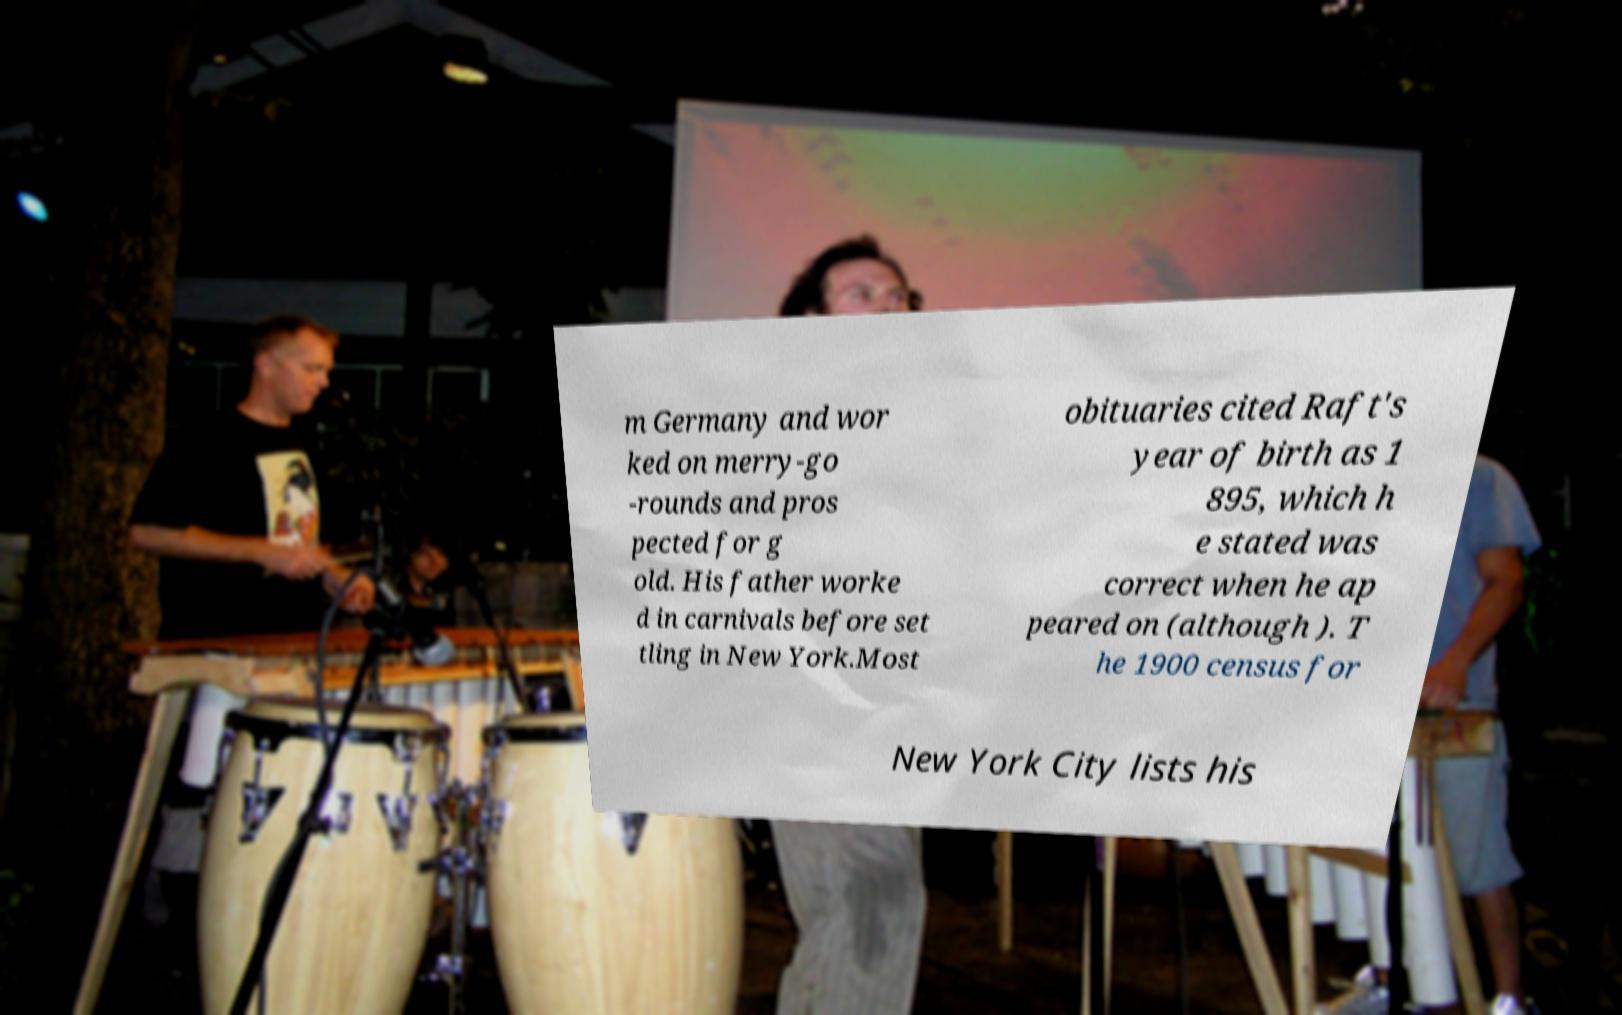Can you accurately transcribe the text from the provided image for me? m Germany and wor ked on merry-go -rounds and pros pected for g old. His father worke d in carnivals before set tling in New York.Most obituaries cited Raft's year of birth as 1 895, which h e stated was correct when he ap peared on (although ). T he 1900 census for New York City lists his 